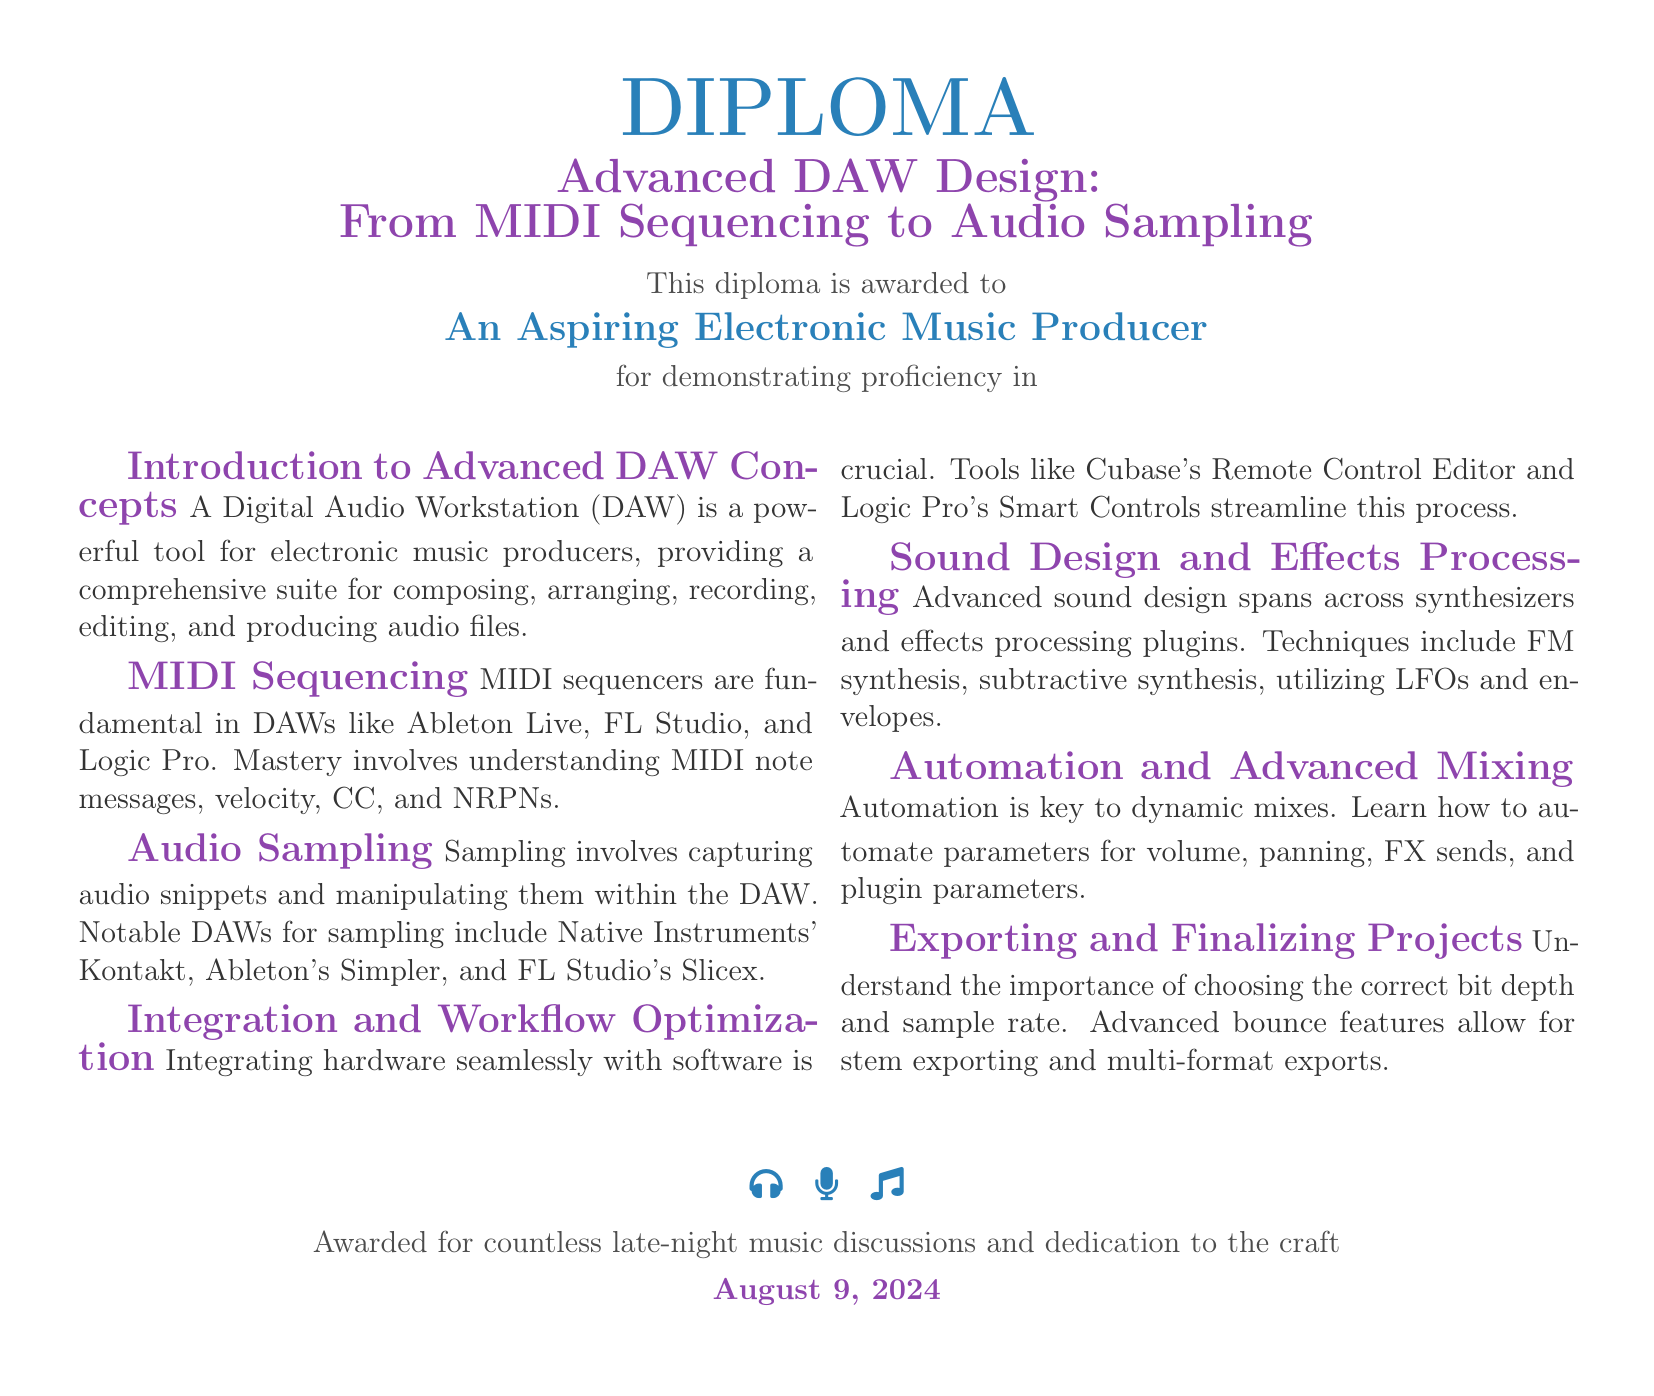What is the title of the diploma? The title of the diploma is explicitly stated under the main heading, which is Advanced DAW Design: From MIDI Sequencing to Audio Sampling.
Answer: Advanced DAW Design: From MIDI Sequencing to Audio Sampling Who is awarded the diploma? The individual receiving the diploma is specifically mentioned in the document as "An Aspiring Electronic Music Producer."
Answer: An Aspiring Electronic Music Producer What are MIDI sequencers fundamental in? The document explains that MIDI sequencers are fundamental in DAWs such as Ableton Live, FL Studio, and Logic Pro.
Answer: DAWs What is emphasized in the section on Automation and Advanced Mixing? The section on Automation and Advanced Mixing highlights the importance of automating parameters for dynamic mixes.
Answer: Dynamic mixes Which tool is mentioned for workflow optimization? The document lists Cubase's Remote Control Editor as a tool for integrating hardware with software.
Answer: Cubase's Remote Control Editor What advanced feature is important for exporting projects? The importance of choosing the correct bit depth and sample rate is emphasized for exporting projects.
Answer: Bit depth and sample rate What type of automation is discussed? The type of automation mentioned includes automation for volume, panning, FX sends, and plugin parameters.
Answer: Volume, panning, FX sends, plugin parameters When was the diploma awarded? The date on which the diploma is awarded is included at the bottom of the document and reflects today's date.
Answer: Today's date 